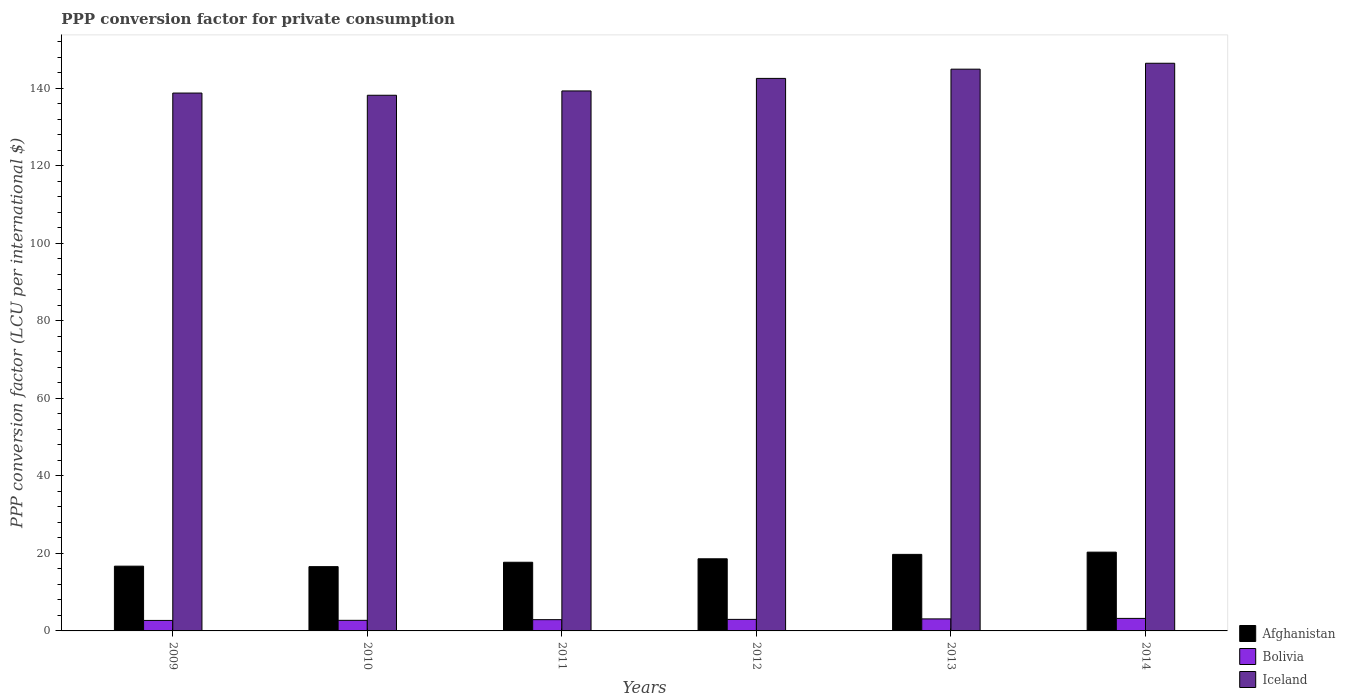How many different coloured bars are there?
Your answer should be very brief. 3. How many groups of bars are there?
Make the answer very short. 6. How many bars are there on the 3rd tick from the right?
Offer a terse response. 3. What is the label of the 4th group of bars from the left?
Your answer should be very brief. 2012. In how many cases, is the number of bars for a given year not equal to the number of legend labels?
Offer a very short reply. 0. What is the PPP conversion factor for private consumption in Bolivia in 2012?
Offer a very short reply. 2.98. Across all years, what is the maximum PPP conversion factor for private consumption in Iceland?
Provide a succinct answer. 146.47. Across all years, what is the minimum PPP conversion factor for private consumption in Afghanistan?
Your response must be concise. 16.59. What is the total PPP conversion factor for private consumption in Iceland in the graph?
Give a very brief answer. 850.29. What is the difference between the PPP conversion factor for private consumption in Bolivia in 2010 and that in 2014?
Make the answer very short. -0.5. What is the difference between the PPP conversion factor for private consumption in Bolivia in 2011 and the PPP conversion factor for private consumption in Iceland in 2010?
Ensure brevity in your answer.  -135.3. What is the average PPP conversion factor for private consumption in Iceland per year?
Make the answer very short. 141.72. In the year 2014, what is the difference between the PPP conversion factor for private consumption in Afghanistan and PPP conversion factor for private consumption in Bolivia?
Provide a short and direct response. 17.1. In how many years, is the PPP conversion factor for private consumption in Afghanistan greater than 44 LCU?
Provide a succinct answer. 0. What is the ratio of the PPP conversion factor for private consumption in Iceland in 2009 to that in 2011?
Your answer should be compact. 1. What is the difference between the highest and the second highest PPP conversion factor for private consumption in Bolivia?
Ensure brevity in your answer.  0.13. What is the difference between the highest and the lowest PPP conversion factor for private consumption in Iceland?
Offer a very short reply. 8.26. Is the sum of the PPP conversion factor for private consumption in Afghanistan in 2013 and 2014 greater than the maximum PPP conversion factor for private consumption in Iceland across all years?
Your response must be concise. No. What does the 1st bar from the left in 2012 represents?
Offer a terse response. Afghanistan. What does the 3rd bar from the right in 2011 represents?
Provide a short and direct response. Afghanistan. Is it the case that in every year, the sum of the PPP conversion factor for private consumption in Afghanistan and PPP conversion factor for private consumption in Bolivia is greater than the PPP conversion factor for private consumption in Iceland?
Your answer should be compact. No. How many years are there in the graph?
Your answer should be very brief. 6. Where does the legend appear in the graph?
Ensure brevity in your answer.  Bottom right. How many legend labels are there?
Provide a succinct answer. 3. What is the title of the graph?
Make the answer very short. PPP conversion factor for private consumption. What is the label or title of the Y-axis?
Offer a terse response. PPP conversion factor (LCU per international $). What is the PPP conversion factor (LCU per international $) in Afghanistan in 2009?
Your response must be concise. 16.71. What is the PPP conversion factor (LCU per international $) of Bolivia in 2009?
Make the answer very short. 2.71. What is the PPP conversion factor (LCU per international $) in Iceland in 2009?
Ensure brevity in your answer.  138.78. What is the PPP conversion factor (LCU per international $) in Afghanistan in 2010?
Your answer should be compact. 16.59. What is the PPP conversion factor (LCU per international $) in Bolivia in 2010?
Give a very brief answer. 2.73. What is the PPP conversion factor (LCU per international $) in Iceland in 2010?
Ensure brevity in your answer.  138.21. What is the PPP conversion factor (LCU per international $) of Afghanistan in 2011?
Offer a very short reply. 17.72. What is the PPP conversion factor (LCU per international $) of Bolivia in 2011?
Your answer should be compact. 2.91. What is the PPP conversion factor (LCU per international $) of Iceland in 2011?
Your answer should be very brief. 139.33. What is the PPP conversion factor (LCU per international $) of Afghanistan in 2012?
Your response must be concise. 18.61. What is the PPP conversion factor (LCU per international $) in Bolivia in 2012?
Make the answer very short. 2.98. What is the PPP conversion factor (LCU per international $) of Iceland in 2012?
Offer a very short reply. 142.56. What is the PPP conversion factor (LCU per international $) in Afghanistan in 2013?
Give a very brief answer. 19.75. What is the PPP conversion factor (LCU per international $) of Bolivia in 2013?
Provide a succinct answer. 3.1. What is the PPP conversion factor (LCU per international $) of Iceland in 2013?
Keep it short and to the point. 144.95. What is the PPP conversion factor (LCU per international $) in Afghanistan in 2014?
Provide a succinct answer. 20.33. What is the PPP conversion factor (LCU per international $) of Bolivia in 2014?
Your answer should be compact. 3.23. What is the PPP conversion factor (LCU per international $) of Iceland in 2014?
Offer a very short reply. 146.47. Across all years, what is the maximum PPP conversion factor (LCU per international $) of Afghanistan?
Ensure brevity in your answer.  20.33. Across all years, what is the maximum PPP conversion factor (LCU per international $) of Bolivia?
Your answer should be very brief. 3.23. Across all years, what is the maximum PPP conversion factor (LCU per international $) in Iceland?
Ensure brevity in your answer.  146.47. Across all years, what is the minimum PPP conversion factor (LCU per international $) of Afghanistan?
Your answer should be compact. 16.59. Across all years, what is the minimum PPP conversion factor (LCU per international $) in Bolivia?
Your answer should be very brief. 2.71. Across all years, what is the minimum PPP conversion factor (LCU per international $) of Iceland?
Offer a terse response. 138.21. What is the total PPP conversion factor (LCU per international $) in Afghanistan in the graph?
Keep it short and to the point. 109.7. What is the total PPP conversion factor (LCU per international $) in Bolivia in the graph?
Offer a terse response. 17.65. What is the total PPP conversion factor (LCU per international $) in Iceland in the graph?
Make the answer very short. 850.29. What is the difference between the PPP conversion factor (LCU per international $) in Afghanistan in 2009 and that in 2010?
Provide a succinct answer. 0.12. What is the difference between the PPP conversion factor (LCU per international $) of Bolivia in 2009 and that in 2010?
Offer a very short reply. -0.02. What is the difference between the PPP conversion factor (LCU per international $) of Iceland in 2009 and that in 2010?
Offer a very short reply. 0.57. What is the difference between the PPP conversion factor (LCU per international $) of Afghanistan in 2009 and that in 2011?
Offer a terse response. -1.01. What is the difference between the PPP conversion factor (LCU per international $) in Bolivia in 2009 and that in 2011?
Provide a short and direct response. -0.2. What is the difference between the PPP conversion factor (LCU per international $) in Iceland in 2009 and that in 2011?
Keep it short and to the point. -0.55. What is the difference between the PPP conversion factor (LCU per international $) of Afghanistan in 2009 and that in 2012?
Keep it short and to the point. -1.9. What is the difference between the PPP conversion factor (LCU per international $) in Bolivia in 2009 and that in 2012?
Ensure brevity in your answer.  -0.27. What is the difference between the PPP conversion factor (LCU per international $) in Iceland in 2009 and that in 2012?
Your answer should be compact. -3.78. What is the difference between the PPP conversion factor (LCU per international $) in Afghanistan in 2009 and that in 2013?
Make the answer very short. -3.04. What is the difference between the PPP conversion factor (LCU per international $) in Bolivia in 2009 and that in 2013?
Your answer should be very brief. -0.4. What is the difference between the PPP conversion factor (LCU per international $) in Iceland in 2009 and that in 2013?
Make the answer very short. -6.17. What is the difference between the PPP conversion factor (LCU per international $) in Afghanistan in 2009 and that in 2014?
Give a very brief answer. -3.62. What is the difference between the PPP conversion factor (LCU per international $) of Bolivia in 2009 and that in 2014?
Keep it short and to the point. -0.52. What is the difference between the PPP conversion factor (LCU per international $) of Iceland in 2009 and that in 2014?
Your answer should be compact. -7.69. What is the difference between the PPP conversion factor (LCU per international $) in Afghanistan in 2010 and that in 2011?
Ensure brevity in your answer.  -1.13. What is the difference between the PPP conversion factor (LCU per international $) of Bolivia in 2010 and that in 2011?
Keep it short and to the point. -0.18. What is the difference between the PPP conversion factor (LCU per international $) of Iceland in 2010 and that in 2011?
Keep it short and to the point. -1.12. What is the difference between the PPP conversion factor (LCU per international $) of Afghanistan in 2010 and that in 2012?
Make the answer very short. -2.03. What is the difference between the PPP conversion factor (LCU per international $) of Bolivia in 2010 and that in 2012?
Ensure brevity in your answer.  -0.25. What is the difference between the PPP conversion factor (LCU per international $) of Iceland in 2010 and that in 2012?
Keep it short and to the point. -4.35. What is the difference between the PPP conversion factor (LCU per international $) in Afghanistan in 2010 and that in 2013?
Provide a succinct answer. -3.16. What is the difference between the PPP conversion factor (LCU per international $) of Bolivia in 2010 and that in 2013?
Your response must be concise. -0.37. What is the difference between the PPP conversion factor (LCU per international $) of Iceland in 2010 and that in 2013?
Provide a succinct answer. -6.73. What is the difference between the PPP conversion factor (LCU per international $) in Afghanistan in 2010 and that in 2014?
Your answer should be very brief. -3.74. What is the difference between the PPP conversion factor (LCU per international $) in Bolivia in 2010 and that in 2014?
Keep it short and to the point. -0.5. What is the difference between the PPP conversion factor (LCU per international $) in Iceland in 2010 and that in 2014?
Offer a very short reply. -8.26. What is the difference between the PPP conversion factor (LCU per international $) of Afghanistan in 2011 and that in 2012?
Offer a terse response. -0.89. What is the difference between the PPP conversion factor (LCU per international $) of Bolivia in 2011 and that in 2012?
Your answer should be compact. -0.07. What is the difference between the PPP conversion factor (LCU per international $) of Iceland in 2011 and that in 2012?
Offer a terse response. -3.24. What is the difference between the PPP conversion factor (LCU per international $) in Afghanistan in 2011 and that in 2013?
Offer a terse response. -2.03. What is the difference between the PPP conversion factor (LCU per international $) in Bolivia in 2011 and that in 2013?
Your answer should be very brief. -0.2. What is the difference between the PPP conversion factor (LCU per international $) of Iceland in 2011 and that in 2013?
Offer a terse response. -5.62. What is the difference between the PPP conversion factor (LCU per international $) of Afghanistan in 2011 and that in 2014?
Your response must be concise. -2.61. What is the difference between the PPP conversion factor (LCU per international $) of Bolivia in 2011 and that in 2014?
Offer a very short reply. -0.32. What is the difference between the PPP conversion factor (LCU per international $) of Iceland in 2011 and that in 2014?
Offer a terse response. -7.14. What is the difference between the PPP conversion factor (LCU per international $) of Afghanistan in 2012 and that in 2013?
Make the answer very short. -1.14. What is the difference between the PPP conversion factor (LCU per international $) in Bolivia in 2012 and that in 2013?
Your response must be concise. -0.12. What is the difference between the PPP conversion factor (LCU per international $) in Iceland in 2012 and that in 2013?
Provide a short and direct response. -2.38. What is the difference between the PPP conversion factor (LCU per international $) in Afghanistan in 2012 and that in 2014?
Keep it short and to the point. -1.71. What is the difference between the PPP conversion factor (LCU per international $) of Bolivia in 2012 and that in 2014?
Make the answer very short. -0.25. What is the difference between the PPP conversion factor (LCU per international $) in Iceland in 2012 and that in 2014?
Give a very brief answer. -3.91. What is the difference between the PPP conversion factor (LCU per international $) in Afghanistan in 2013 and that in 2014?
Give a very brief answer. -0.58. What is the difference between the PPP conversion factor (LCU per international $) of Bolivia in 2013 and that in 2014?
Your response must be concise. -0.13. What is the difference between the PPP conversion factor (LCU per international $) in Iceland in 2013 and that in 2014?
Offer a very short reply. -1.52. What is the difference between the PPP conversion factor (LCU per international $) in Afghanistan in 2009 and the PPP conversion factor (LCU per international $) in Bolivia in 2010?
Ensure brevity in your answer.  13.98. What is the difference between the PPP conversion factor (LCU per international $) of Afghanistan in 2009 and the PPP conversion factor (LCU per international $) of Iceland in 2010?
Your response must be concise. -121.5. What is the difference between the PPP conversion factor (LCU per international $) in Bolivia in 2009 and the PPP conversion factor (LCU per international $) in Iceland in 2010?
Keep it short and to the point. -135.5. What is the difference between the PPP conversion factor (LCU per international $) of Afghanistan in 2009 and the PPP conversion factor (LCU per international $) of Bolivia in 2011?
Your answer should be very brief. 13.8. What is the difference between the PPP conversion factor (LCU per international $) of Afghanistan in 2009 and the PPP conversion factor (LCU per international $) of Iceland in 2011?
Your response must be concise. -122.62. What is the difference between the PPP conversion factor (LCU per international $) of Bolivia in 2009 and the PPP conversion factor (LCU per international $) of Iceland in 2011?
Keep it short and to the point. -136.62. What is the difference between the PPP conversion factor (LCU per international $) of Afghanistan in 2009 and the PPP conversion factor (LCU per international $) of Bolivia in 2012?
Offer a terse response. 13.73. What is the difference between the PPP conversion factor (LCU per international $) in Afghanistan in 2009 and the PPP conversion factor (LCU per international $) in Iceland in 2012?
Ensure brevity in your answer.  -125.85. What is the difference between the PPP conversion factor (LCU per international $) of Bolivia in 2009 and the PPP conversion factor (LCU per international $) of Iceland in 2012?
Offer a terse response. -139.86. What is the difference between the PPP conversion factor (LCU per international $) of Afghanistan in 2009 and the PPP conversion factor (LCU per international $) of Bolivia in 2013?
Provide a succinct answer. 13.61. What is the difference between the PPP conversion factor (LCU per international $) in Afghanistan in 2009 and the PPP conversion factor (LCU per international $) in Iceland in 2013?
Your response must be concise. -128.24. What is the difference between the PPP conversion factor (LCU per international $) of Bolivia in 2009 and the PPP conversion factor (LCU per international $) of Iceland in 2013?
Give a very brief answer. -142.24. What is the difference between the PPP conversion factor (LCU per international $) of Afghanistan in 2009 and the PPP conversion factor (LCU per international $) of Bolivia in 2014?
Ensure brevity in your answer.  13.48. What is the difference between the PPP conversion factor (LCU per international $) in Afghanistan in 2009 and the PPP conversion factor (LCU per international $) in Iceland in 2014?
Keep it short and to the point. -129.76. What is the difference between the PPP conversion factor (LCU per international $) in Bolivia in 2009 and the PPP conversion factor (LCU per international $) in Iceland in 2014?
Make the answer very short. -143.76. What is the difference between the PPP conversion factor (LCU per international $) in Afghanistan in 2010 and the PPP conversion factor (LCU per international $) in Bolivia in 2011?
Your response must be concise. 13.68. What is the difference between the PPP conversion factor (LCU per international $) in Afghanistan in 2010 and the PPP conversion factor (LCU per international $) in Iceland in 2011?
Provide a short and direct response. -122.74. What is the difference between the PPP conversion factor (LCU per international $) in Bolivia in 2010 and the PPP conversion factor (LCU per international $) in Iceland in 2011?
Your answer should be compact. -136.6. What is the difference between the PPP conversion factor (LCU per international $) of Afghanistan in 2010 and the PPP conversion factor (LCU per international $) of Bolivia in 2012?
Provide a short and direct response. 13.61. What is the difference between the PPP conversion factor (LCU per international $) in Afghanistan in 2010 and the PPP conversion factor (LCU per international $) in Iceland in 2012?
Ensure brevity in your answer.  -125.98. What is the difference between the PPP conversion factor (LCU per international $) in Bolivia in 2010 and the PPP conversion factor (LCU per international $) in Iceland in 2012?
Offer a very short reply. -139.83. What is the difference between the PPP conversion factor (LCU per international $) of Afghanistan in 2010 and the PPP conversion factor (LCU per international $) of Bolivia in 2013?
Provide a short and direct response. 13.48. What is the difference between the PPP conversion factor (LCU per international $) of Afghanistan in 2010 and the PPP conversion factor (LCU per international $) of Iceland in 2013?
Make the answer very short. -128.36. What is the difference between the PPP conversion factor (LCU per international $) in Bolivia in 2010 and the PPP conversion factor (LCU per international $) in Iceland in 2013?
Your answer should be compact. -142.22. What is the difference between the PPP conversion factor (LCU per international $) of Afghanistan in 2010 and the PPP conversion factor (LCU per international $) of Bolivia in 2014?
Your answer should be very brief. 13.36. What is the difference between the PPP conversion factor (LCU per international $) in Afghanistan in 2010 and the PPP conversion factor (LCU per international $) in Iceland in 2014?
Make the answer very short. -129.88. What is the difference between the PPP conversion factor (LCU per international $) in Bolivia in 2010 and the PPP conversion factor (LCU per international $) in Iceland in 2014?
Offer a terse response. -143.74. What is the difference between the PPP conversion factor (LCU per international $) in Afghanistan in 2011 and the PPP conversion factor (LCU per international $) in Bolivia in 2012?
Make the answer very short. 14.74. What is the difference between the PPP conversion factor (LCU per international $) in Afghanistan in 2011 and the PPP conversion factor (LCU per international $) in Iceland in 2012?
Give a very brief answer. -124.84. What is the difference between the PPP conversion factor (LCU per international $) of Bolivia in 2011 and the PPP conversion factor (LCU per international $) of Iceland in 2012?
Provide a short and direct response. -139.66. What is the difference between the PPP conversion factor (LCU per international $) of Afghanistan in 2011 and the PPP conversion factor (LCU per international $) of Bolivia in 2013?
Ensure brevity in your answer.  14.62. What is the difference between the PPP conversion factor (LCU per international $) in Afghanistan in 2011 and the PPP conversion factor (LCU per international $) in Iceland in 2013?
Provide a short and direct response. -127.23. What is the difference between the PPP conversion factor (LCU per international $) in Bolivia in 2011 and the PPP conversion factor (LCU per international $) in Iceland in 2013?
Keep it short and to the point. -142.04. What is the difference between the PPP conversion factor (LCU per international $) of Afghanistan in 2011 and the PPP conversion factor (LCU per international $) of Bolivia in 2014?
Ensure brevity in your answer.  14.49. What is the difference between the PPP conversion factor (LCU per international $) of Afghanistan in 2011 and the PPP conversion factor (LCU per international $) of Iceland in 2014?
Ensure brevity in your answer.  -128.75. What is the difference between the PPP conversion factor (LCU per international $) in Bolivia in 2011 and the PPP conversion factor (LCU per international $) in Iceland in 2014?
Provide a succinct answer. -143.56. What is the difference between the PPP conversion factor (LCU per international $) of Afghanistan in 2012 and the PPP conversion factor (LCU per international $) of Bolivia in 2013?
Ensure brevity in your answer.  15.51. What is the difference between the PPP conversion factor (LCU per international $) of Afghanistan in 2012 and the PPP conversion factor (LCU per international $) of Iceland in 2013?
Ensure brevity in your answer.  -126.33. What is the difference between the PPP conversion factor (LCU per international $) in Bolivia in 2012 and the PPP conversion factor (LCU per international $) in Iceland in 2013?
Provide a short and direct response. -141.97. What is the difference between the PPP conversion factor (LCU per international $) of Afghanistan in 2012 and the PPP conversion factor (LCU per international $) of Bolivia in 2014?
Your answer should be compact. 15.38. What is the difference between the PPP conversion factor (LCU per international $) in Afghanistan in 2012 and the PPP conversion factor (LCU per international $) in Iceland in 2014?
Your answer should be compact. -127.86. What is the difference between the PPP conversion factor (LCU per international $) in Bolivia in 2012 and the PPP conversion factor (LCU per international $) in Iceland in 2014?
Provide a short and direct response. -143.49. What is the difference between the PPP conversion factor (LCU per international $) in Afghanistan in 2013 and the PPP conversion factor (LCU per international $) in Bolivia in 2014?
Provide a short and direct response. 16.52. What is the difference between the PPP conversion factor (LCU per international $) of Afghanistan in 2013 and the PPP conversion factor (LCU per international $) of Iceland in 2014?
Give a very brief answer. -126.72. What is the difference between the PPP conversion factor (LCU per international $) in Bolivia in 2013 and the PPP conversion factor (LCU per international $) in Iceland in 2014?
Make the answer very short. -143.37. What is the average PPP conversion factor (LCU per international $) of Afghanistan per year?
Your answer should be compact. 18.28. What is the average PPP conversion factor (LCU per international $) of Bolivia per year?
Provide a short and direct response. 2.94. What is the average PPP conversion factor (LCU per international $) in Iceland per year?
Offer a very short reply. 141.72. In the year 2009, what is the difference between the PPP conversion factor (LCU per international $) in Afghanistan and PPP conversion factor (LCU per international $) in Bolivia?
Give a very brief answer. 14. In the year 2009, what is the difference between the PPP conversion factor (LCU per international $) in Afghanistan and PPP conversion factor (LCU per international $) in Iceland?
Give a very brief answer. -122.07. In the year 2009, what is the difference between the PPP conversion factor (LCU per international $) of Bolivia and PPP conversion factor (LCU per international $) of Iceland?
Make the answer very short. -136.07. In the year 2010, what is the difference between the PPP conversion factor (LCU per international $) in Afghanistan and PPP conversion factor (LCU per international $) in Bolivia?
Give a very brief answer. 13.86. In the year 2010, what is the difference between the PPP conversion factor (LCU per international $) in Afghanistan and PPP conversion factor (LCU per international $) in Iceland?
Offer a very short reply. -121.63. In the year 2010, what is the difference between the PPP conversion factor (LCU per international $) in Bolivia and PPP conversion factor (LCU per international $) in Iceland?
Provide a short and direct response. -135.48. In the year 2011, what is the difference between the PPP conversion factor (LCU per international $) of Afghanistan and PPP conversion factor (LCU per international $) of Bolivia?
Provide a succinct answer. 14.81. In the year 2011, what is the difference between the PPP conversion factor (LCU per international $) in Afghanistan and PPP conversion factor (LCU per international $) in Iceland?
Keep it short and to the point. -121.61. In the year 2011, what is the difference between the PPP conversion factor (LCU per international $) in Bolivia and PPP conversion factor (LCU per international $) in Iceland?
Give a very brief answer. -136.42. In the year 2012, what is the difference between the PPP conversion factor (LCU per international $) in Afghanistan and PPP conversion factor (LCU per international $) in Bolivia?
Offer a very short reply. 15.63. In the year 2012, what is the difference between the PPP conversion factor (LCU per international $) in Afghanistan and PPP conversion factor (LCU per international $) in Iceland?
Your response must be concise. -123.95. In the year 2012, what is the difference between the PPP conversion factor (LCU per international $) of Bolivia and PPP conversion factor (LCU per international $) of Iceland?
Give a very brief answer. -139.59. In the year 2013, what is the difference between the PPP conversion factor (LCU per international $) of Afghanistan and PPP conversion factor (LCU per international $) of Bolivia?
Offer a terse response. 16.64. In the year 2013, what is the difference between the PPP conversion factor (LCU per international $) of Afghanistan and PPP conversion factor (LCU per international $) of Iceland?
Your answer should be very brief. -125.2. In the year 2013, what is the difference between the PPP conversion factor (LCU per international $) of Bolivia and PPP conversion factor (LCU per international $) of Iceland?
Make the answer very short. -141.84. In the year 2014, what is the difference between the PPP conversion factor (LCU per international $) in Afghanistan and PPP conversion factor (LCU per international $) in Bolivia?
Your answer should be compact. 17.1. In the year 2014, what is the difference between the PPP conversion factor (LCU per international $) in Afghanistan and PPP conversion factor (LCU per international $) in Iceland?
Keep it short and to the point. -126.14. In the year 2014, what is the difference between the PPP conversion factor (LCU per international $) of Bolivia and PPP conversion factor (LCU per international $) of Iceland?
Ensure brevity in your answer.  -143.24. What is the ratio of the PPP conversion factor (LCU per international $) of Afghanistan in 2009 to that in 2010?
Make the answer very short. 1.01. What is the ratio of the PPP conversion factor (LCU per international $) of Afghanistan in 2009 to that in 2011?
Your answer should be compact. 0.94. What is the ratio of the PPP conversion factor (LCU per international $) of Bolivia in 2009 to that in 2011?
Your answer should be very brief. 0.93. What is the ratio of the PPP conversion factor (LCU per international $) of Afghanistan in 2009 to that in 2012?
Provide a succinct answer. 0.9. What is the ratio of the PPP conversion factor (LCU per international $) in Iceland in 2009 to that in 2012?
Your response must be concise. 0.97. What is the ratio of the PPP conversion factor (LCU per international $) of Afghanistan in 2009 to that in 2013?
Your answer should be compact. 0.85. What is the ratio of the PPP conversion factor (LCU per international $) in Bolivia in 2009 to that in 2013?
Offer a terse response. 0.87. What is the ratio of the PPP conversion factor (LCU per international $) in Iceland in 2009 to that in 2013?
Make the answer very short. 0.96. What is the ratio of the PPP conversion factor (LCU per international $) of Afghanistan in 2009 to that in 2014?
Your answer should be compact. 0.82. What is the ratio of the PPP conversion factor (LCU per international $) in Bolivia in 2009 to that in 2014?
Provide a succinct answer. 0.84. What is the ratio of the PPP conversion factor (LCU per international $) in Iceland in 2009 to that in 2014?
Provide a short and direct response. 0.95. What is the ratio of the PPP conversion factor (LCU per international $) in Afghanistan in 2010 to that in 2011?
Give a very brief answer. 0.94. What is the ratio of the PPP conversion factor (LCU per international $) in Bolivia in 2010 to that in 2011?
Ensure brevity in your answer.  0.94. What is the ratio of the PPP conversion factor (LCU per international $) of Afghanistan in 2010 to that in 2012?
Ensure brevity in your answer.  0.89. What is the ratio of the PPP conversion factor (LCU per international $) of Bolivia in 2010 to that in 2012?
Offer a very short reply. 0.92. What is the ratio of the PPP conversion factor (LCU per international $) of Iceland in 2010 to that in 2012?
Your response must be concise. 0.97. What is the ratio of the PPP conversion factor (LCU per international $) in Afghanistan in 2010 to that in 2013?
Your answer should be compact. 0.84. What is the ratio of the PPP conversion factor (LCU per international $) in Bolivia in 2010 to that in 2013?
Provide a succinct answer. 0.88. What is the ratio of the PPP conversion factor (LCU per international $) of Iceland in 2010 to that in 2013?
Your response must be concise. 0.95. What is the ratio of the PPP conversion factor (LCU per international $) in Afghanistan in 2010 to that in 2014?
Keep it short and to the point. 0.82. What is the ratio of the PPP conversion factor (LCU per international $) in Bolivia in 2010 to that in 2014?
Your answer should be very brief. 0.85. What is the ratio of the PPP conversion factor (LCU per international $) of Iceland in 2010 to that in 2014?
Give a very brief answer. 0.94. What is the ratio of the PPP conversion factor (LCU per international $) of Bolivia in 2011 to that in 2012?
Keep it short and to the point. 0.98. What is the ratio of the PPP conversion factor (LCU per international $) in Iceland in 2011 to that in 2012?
Make the answer very short. 0.98. What is the ratio of the PPP conversion factor (LCU per international $) in Afghanistan in 2011 to that in 2013?
Provide a short and direct response. 0.9. What is the ratio of the PPP conversion factor (LCU per international $) of Bolivia in 2011 to that in 2013?
Offer a very short reply. 0.94. What is the ratio of the PPP conversion factor (LCU per international $) in Iceland in 2011 to that in 2013?
Offer a very short reply. 0.96. What is the ratio of the PPP conversion factor (LCU per international $) in Afghanistan in 2011 to that in 2014?
Your answer should be very brief. 0.87. What is the ratio of the PPP conversion factor (LCU per international $) in Bolivia in 2011 to that in 2014?
Your response must be concise. 0.9. What is the ratio of the PPP conversion factor (LCU per international $) of Iceland in 2011 to that in 2014?
Your answer should be compact. 0.95. What is the ratio of the PPP conversion factor (LCU per international $) in Afghanistan in 2012 to that in 2013?
Your response must be concise. 0.94. What is the ratio of the PPP conversion factor (LCU per international $) of Bolivia in 2012 to that in 2013?
Your response must be concise. 0.96. What is the ratio of the PPP conversion factor (LCU per international $) in Iceland in 2012 to that in 2013?
Make the answer very short. 0.98. What is the ratio of the PPP conversion factor (LCU per international $) in Afghanistan in 2012 to that in 2014?
Ensure brevity in your answer.  0.92. What is the ratio of the PPP conversion factor (LCU per international $) in Bolivia in 2012 to that in 2014?
Offer a very short reply. 0.92. What is the ratio of the PPP conversion factor (LCU per international $) of Iceland in 2012 to that in 2014?
Make the answer very short. 0.97. What is the ratio of the PPP conversion factor (LCU per international $) in Afghanistan in 2013 to that in 2014?
Your response must be concise. 0.97. What is the ratio of the PPP conversion factor (LCU per international $) in Bolivia in 2013 to that in 2014?
Ensure brevity in your answer.  0.96. What is the ratio of the PPP conversion factor (LCU per international $) in Iceland in 2013 to that in 2014?
Your answer should be compact. 0.99. What is the difference between the highest and the second highest PPP conversion factor (LCU per international $) in Afghanistan?
Your answer should be very brief. 0.58. What is the difference between the highest and the second highest PPP conversion factor (LCU per international $) of Bolivia?
Provide a short and direct response. 0.13. What is the difference between the highest and the second highest PPP conversion factor (LCU per international $) in Iceland?
Your answer should be compact. 1.52. What is the difference between the highest and the lowest PPP conversion factor (LCU per international $) of Afghanistan?
Keep it short and to the point. 3.74. What is the difference between the highest and the lowest PPP conversion factor (LCU per international $) in Bolivia?
Give a very brief answer. 0.52. What is the difference between the highest and the lowest PPP conversion factor (LCU per international $) in Iceland?
Your answer should be very brief. 8.26. 